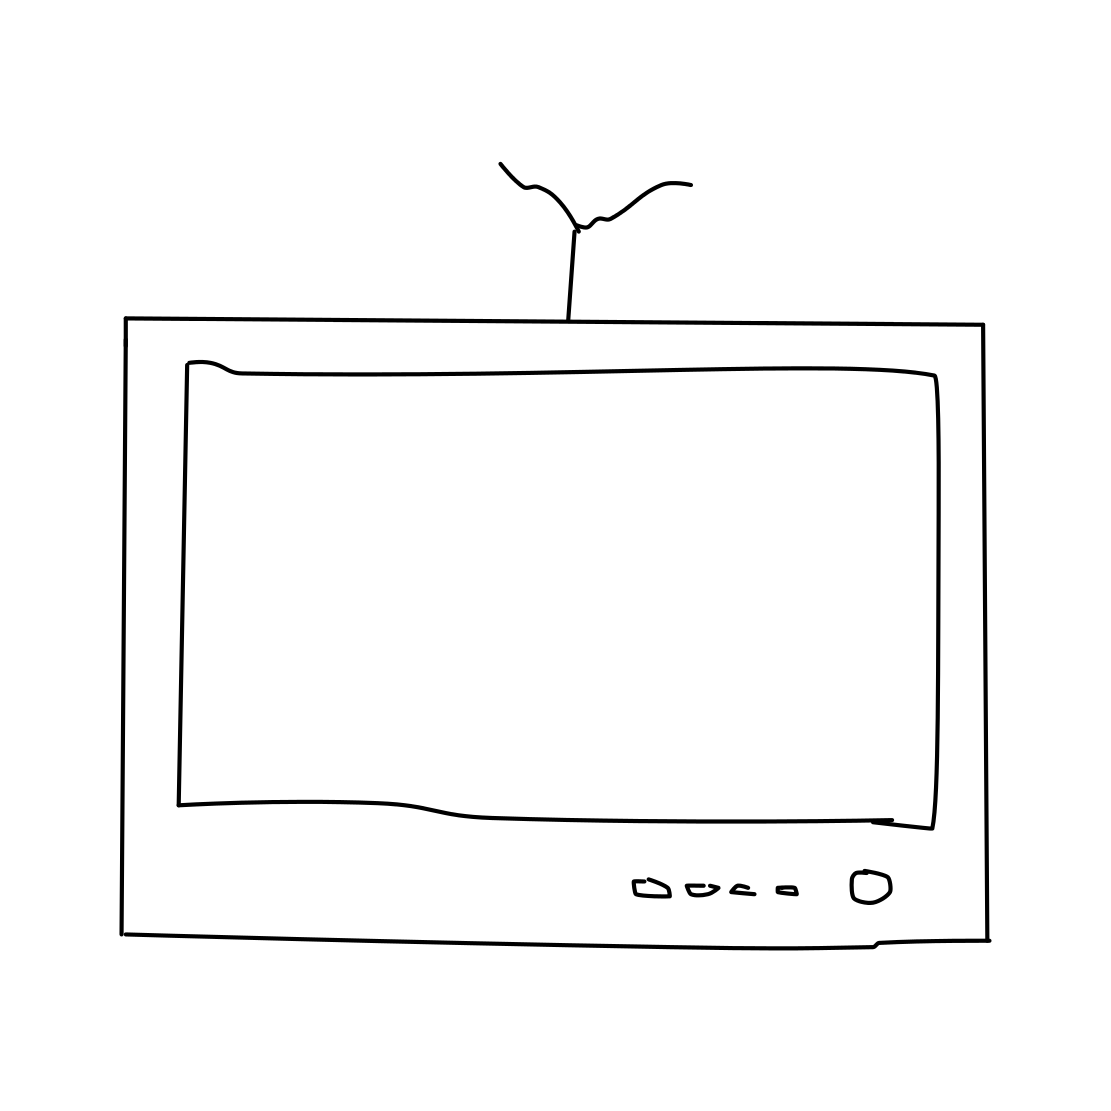If this TV were real, what kind of functionality might it have? If this were a functioning TV model, considering its classic design, it would likely feature basic functionalities such as channel tuning using the rotary dials, volume control, and maybe a few input options like an antenna or a basic AV input for connecting a VCR. It wouldn't have modern features like internet connectivity or high-definition display. 